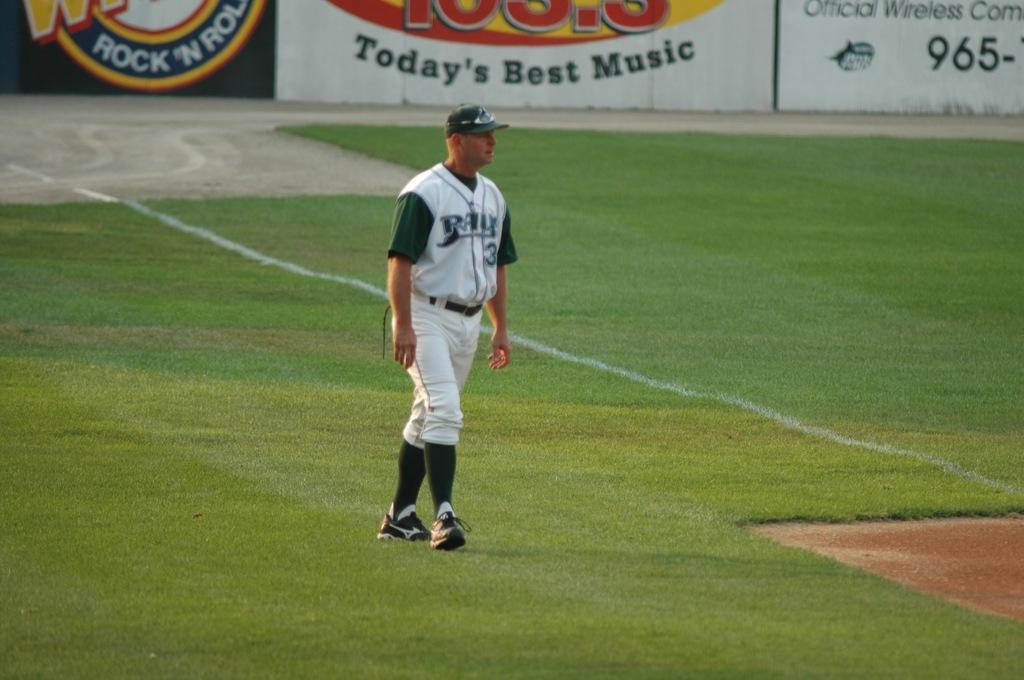<image>
Provide a brief description of the given image. Player number 3 for the Rays stands in the foul ball zone in the baseball stadium. 